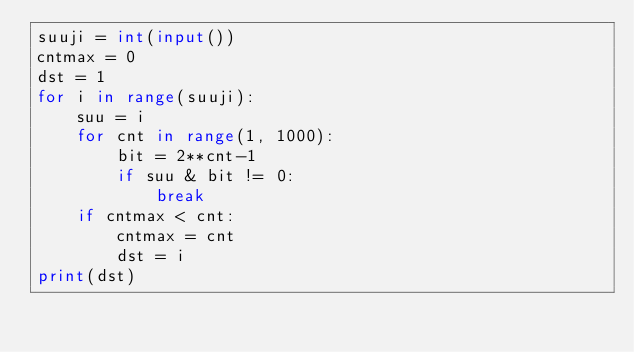<code> <loc_0><loc_0><loc_500><loc_500><_Python_>suuji = int(input())
cntmax = 0
dst = 1
for i in range(suuji):
    suu = i
    for cnt in range(1, 1000):
        bit = 2**cnt-1
        if suu & bit != 0:
            break
    if cntmax < cnt:
        cntmax = cnt
        dst = i
print(dst)
</code> 